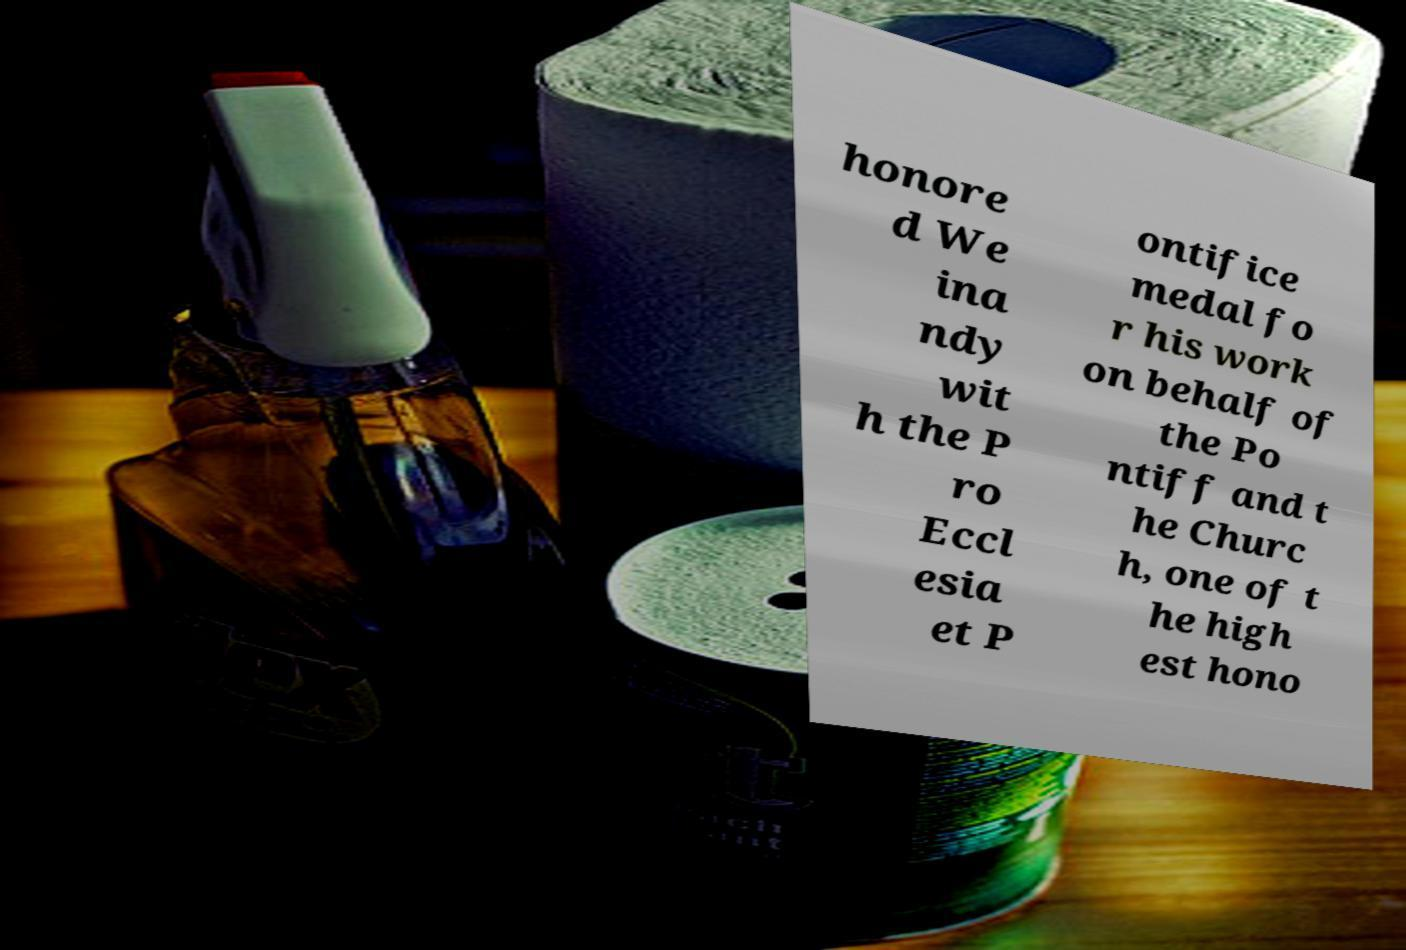There's text embedded in this image that I need extracted. Can you transcribe it verbatim? honore d We ina ndy wit h the P ro Eccl esia et P ontifice medal fo r his work on behalf of the Po ntiff and t he Churc h, one of t he high est hono 